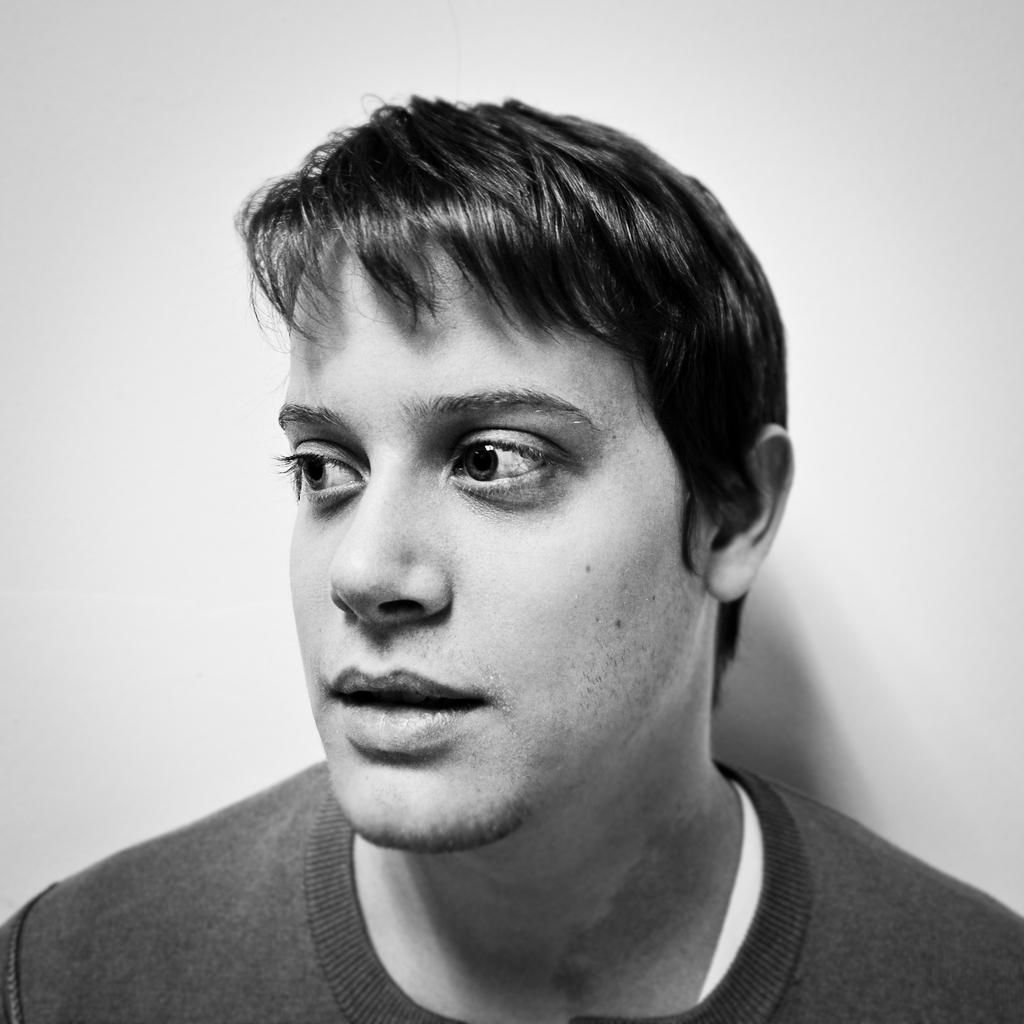What is the main subject of the image? There is a person in the image. What can be seen in the background of the image? The background of the image is white. What type of drug is the person holding in the image? There is no drug present in the image; it features a person with a white background. 